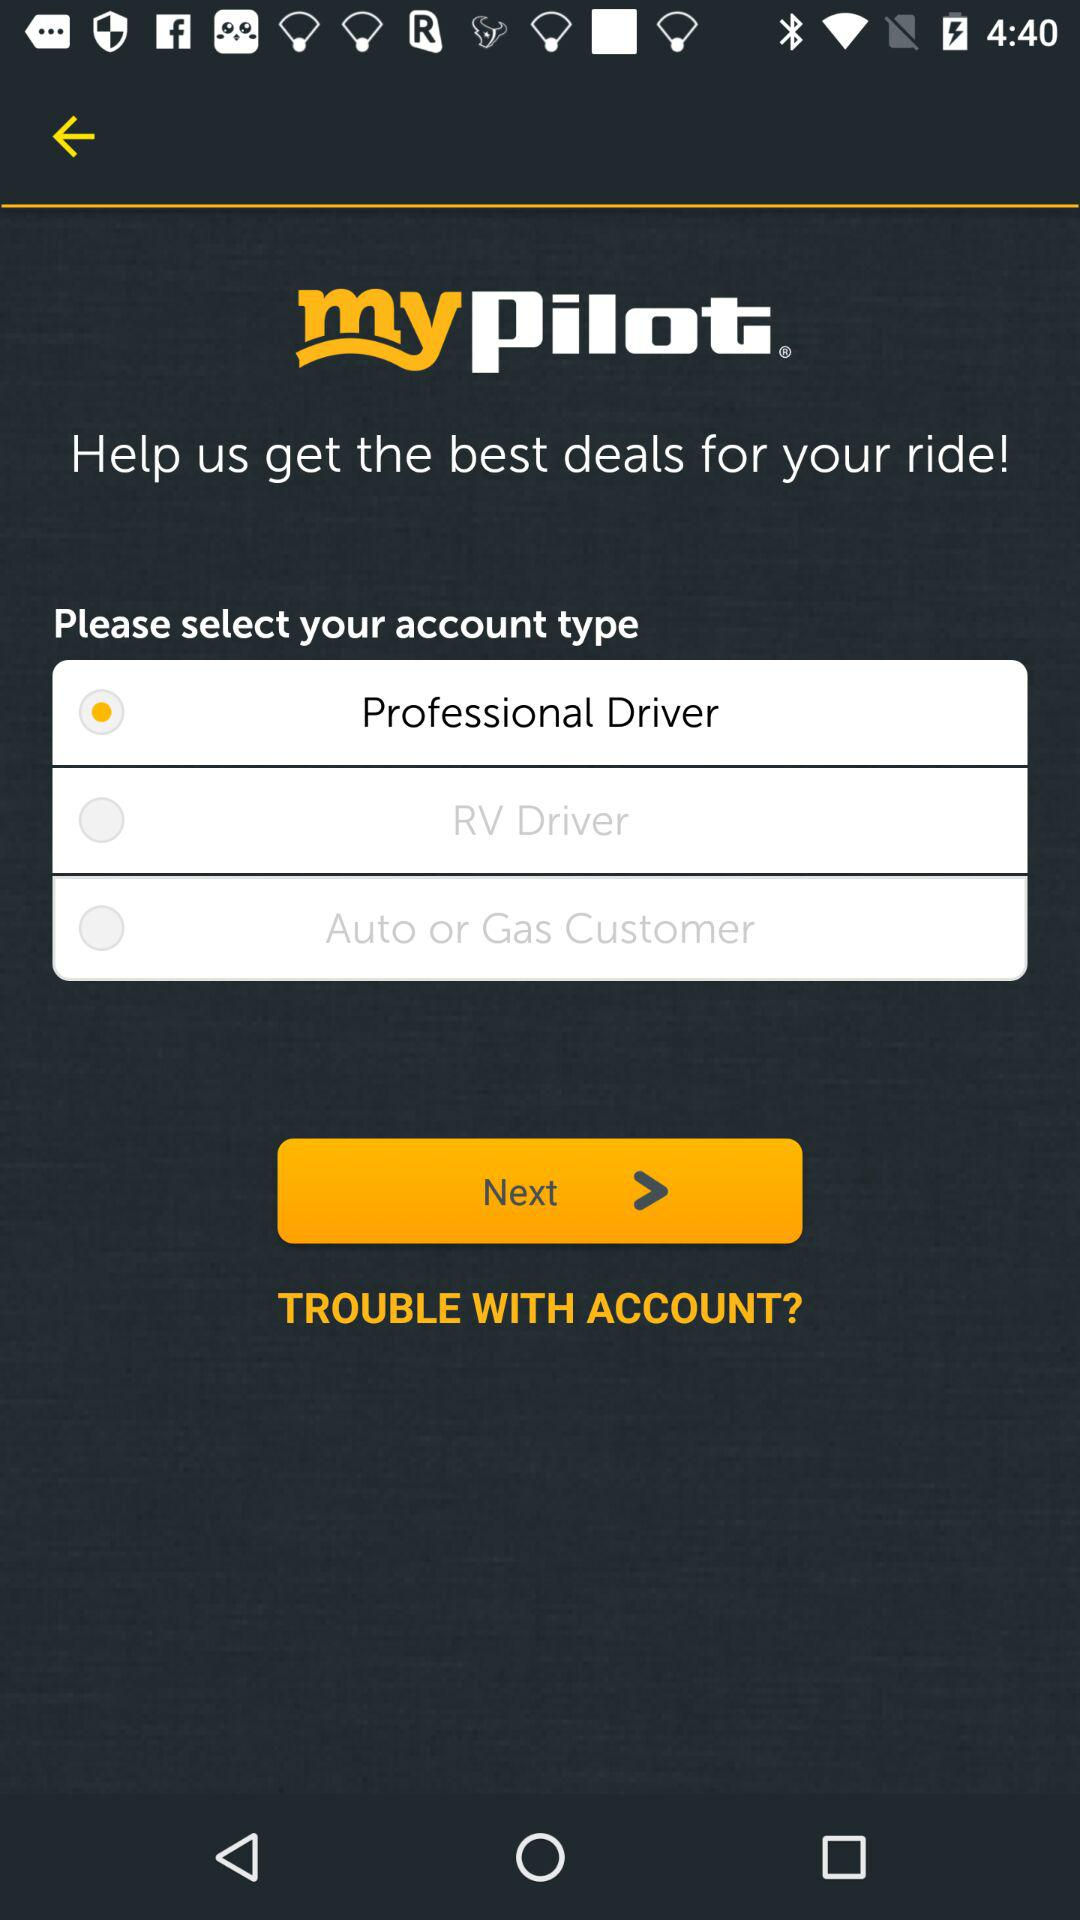Which account type is selected? The selected account type is "Professional Driver". 